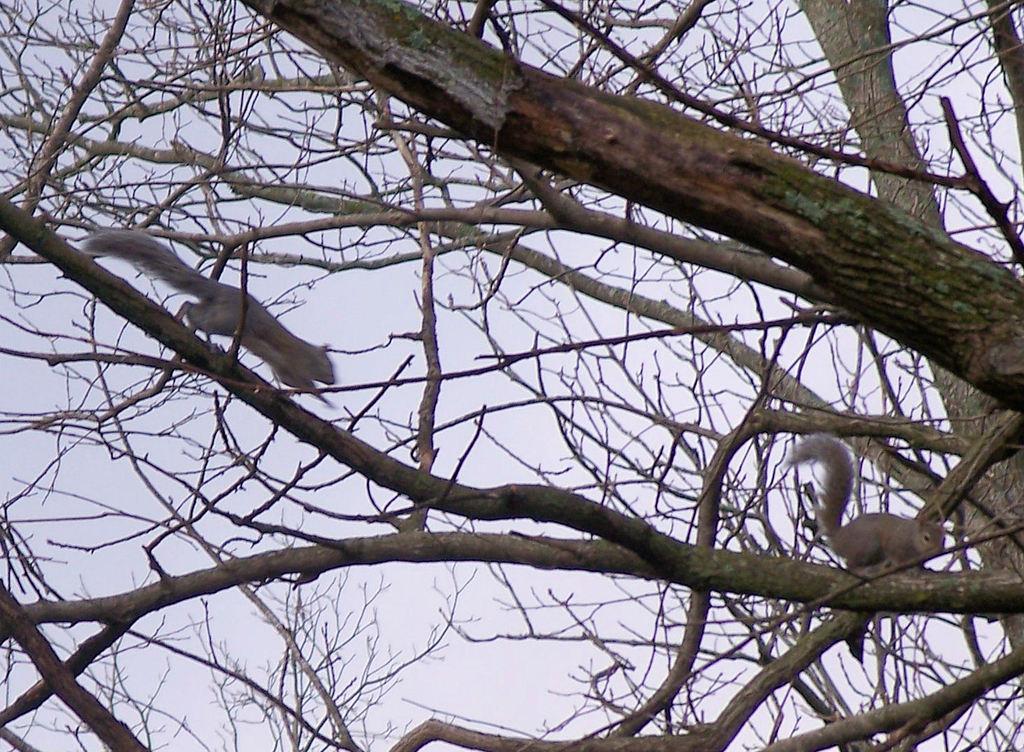How many squirrels are in the image? There are two squirrels in the image. Where are the squirrels located? The squirrels are on the branches of a tree. What else can be seen in the image besides the squirrels? There is a tree in the image. What is visible behind the tree in the image? The sky is visible behind the tree in the image. How many eggs are being carried by the squirrels in the image? There are no eggs present in the image; the squirrels are on the branches of a tree. What type of bed can be seen in the image? There is no bed present in the image; it features two squirrels on a tree branch with the sky visible in the background. 